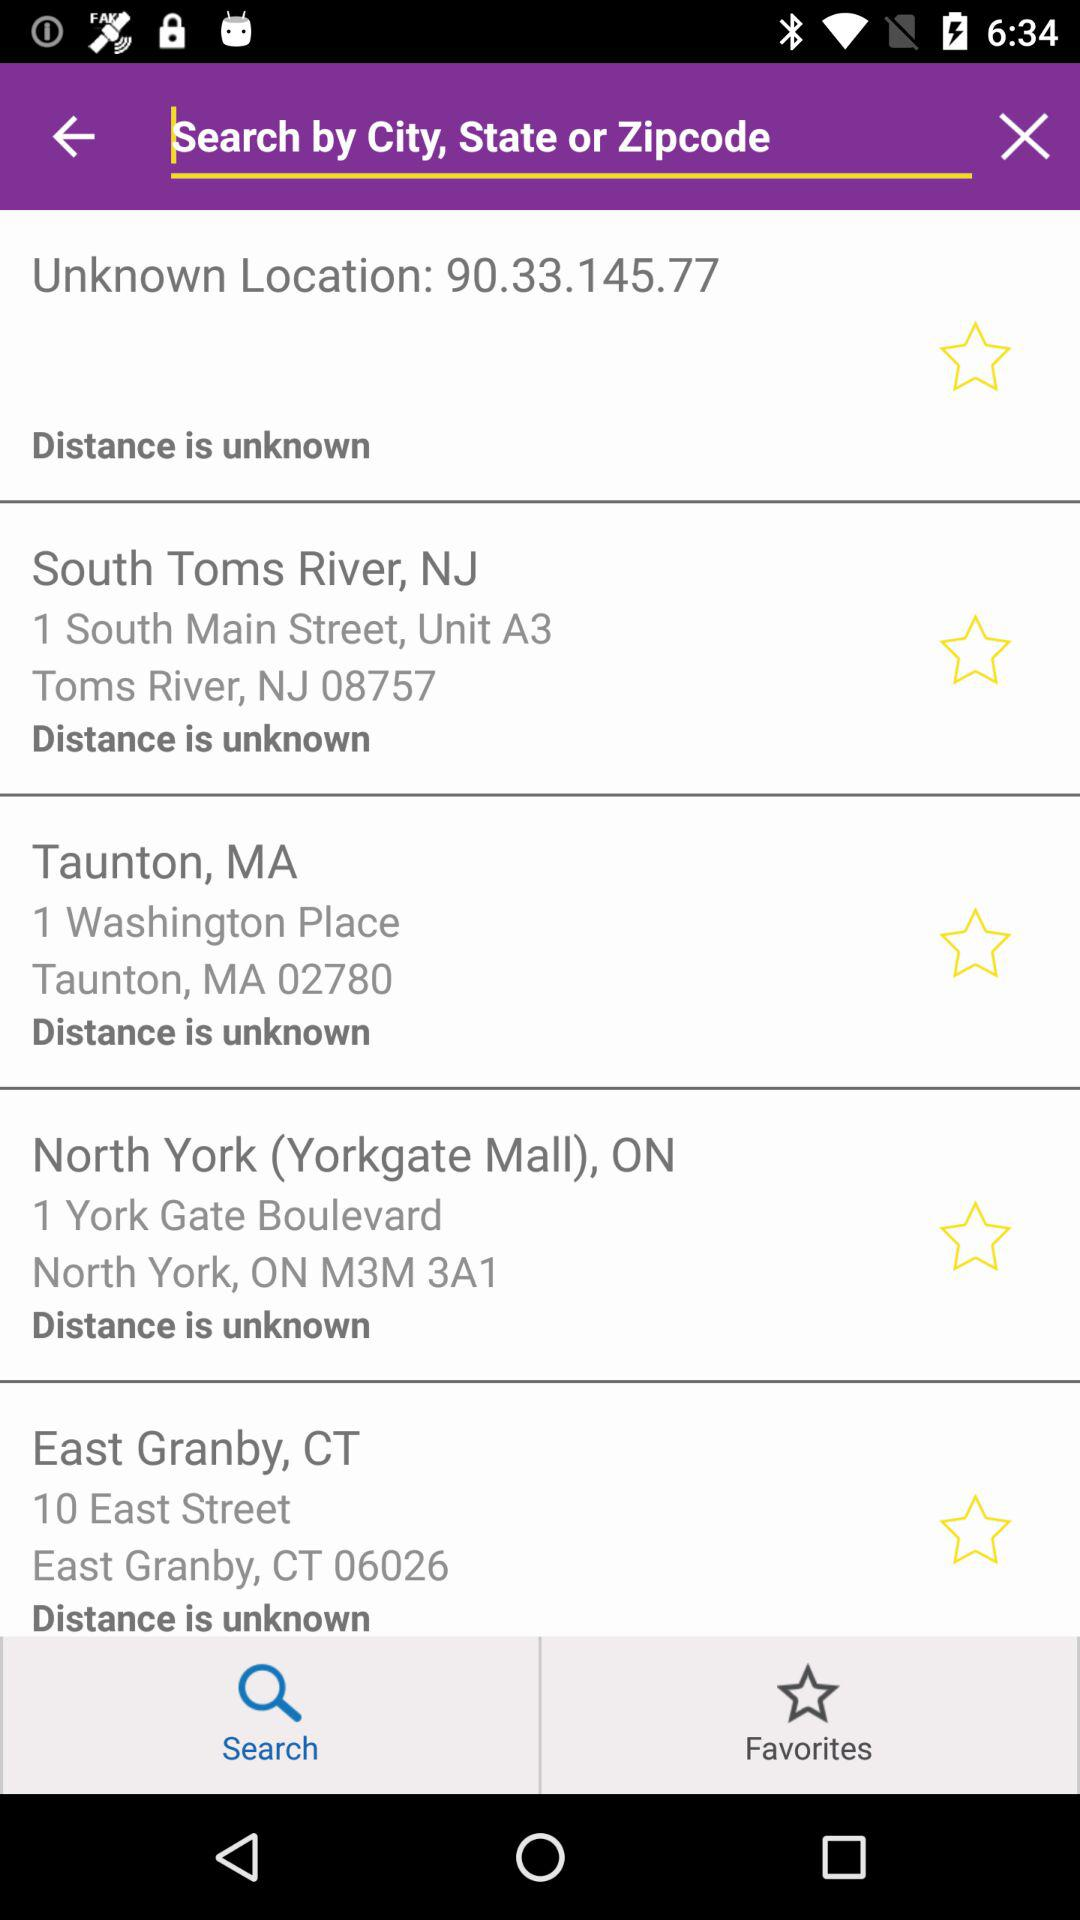Which option is selected? The selected option is "Search". 